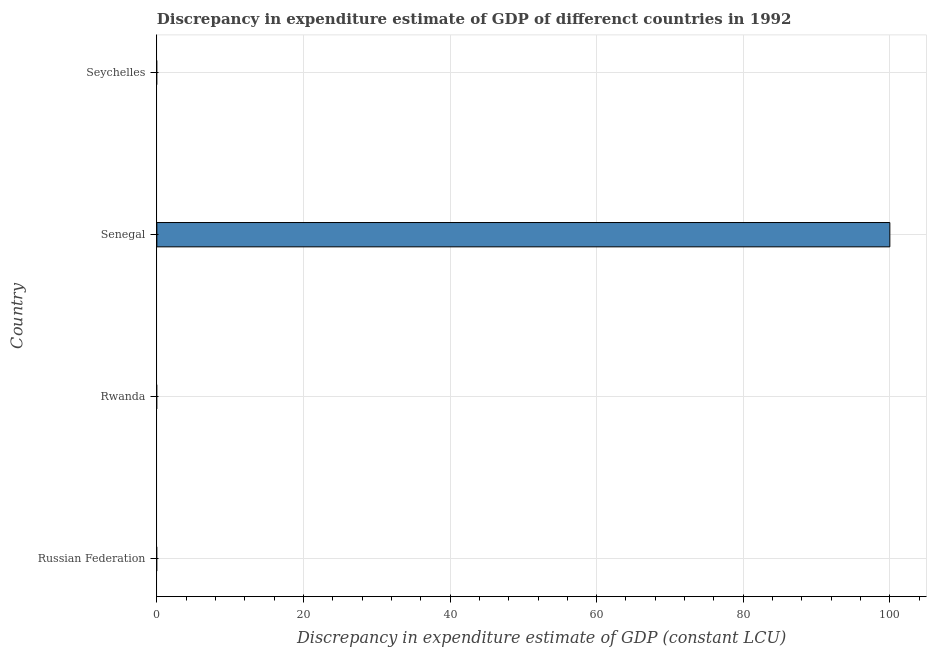Does the graph contain grids?
Your answer should be very brief. Yes. What is the title of the graph?
Offer a terse response. Discrepancy in expenditure estimate of GDP of differenct countries in 1992. What is the label or title of the X-axis?
Make the answer very short. Discrepancy in expenditure estimate of GDP (constant LCU). In which country was the discrepancy in expenditure estimate of gdp maximum?
Ensure brevity in your answer.  Senegal. What is the average discrepancy in expenditure estimate of gdp per country?
Provide a short and direct response. 25. What is the median discrepancy in expenditure estimate of gdp?
Provide a succinct answer. 0. In how many countries, is the discrepancy in expenditure estimate of gdp greater than 96 LCU?
Offer a terse response. 1. In how many countries, is the discrepancy in expenditure estimate of gdp greater than the average discrepancy in expenditure estimate of gdp taken over all countries?
Provide a short and direct response. 1. How many bars are there?
Offer a terse response. 1. Are all the bars in the graph horizontal?
Offer a terse response. Yes. What is the difference between two consecutive major ticks on the X-axis?
Keep it short and to the point. 20. Are the values on the major ticks of X-axis written in scientific E-notation?
Keep it short and to the point. No. What is the Discrepancy in expenditure estimate of GDP (constant LCU) in Rwanda?
Your answer should be very brief. 0. What is the Discrepancy in expenditure estimate of GDP (constant LCU) in Senegal?
Provide a succinct answer. 100. 